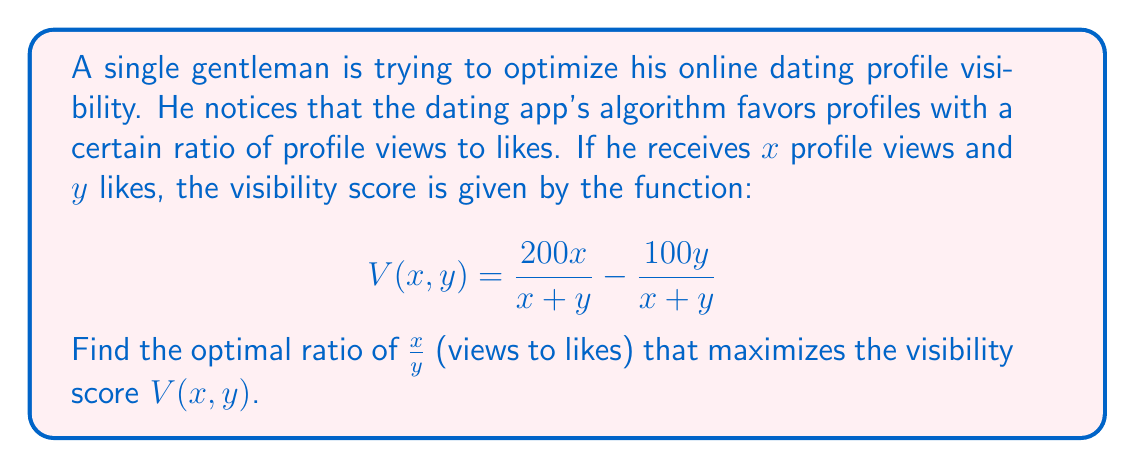Provide a solution to this math problem. To find the optimal ratio, we need to express the visibility score in terms of the ratio $r = \frac{x}{y}$ and then find the maximum value of this function.

1) Let $r = \frac{x}{y}$, so $x = ry$

2) Substitute this into the visibility score function:

   $$V(r) = \frac{200ry}{ry+y} - \frac{100y}{ry+y}$$

3) Simplify:

   $$V(r) = \frac{200r}{r+1} - \frac{100}{r+1}$$

4) To find the maximum, differentiate $V(r)$ with respect to $r$ and set it to zero:

   $$\frac{dV}{dr} = \frac{200(r+1) - 200r}{(r+1)^2} + \frac{100}{(r+1)^2} = \frac{200+100}{(r+1)^2} = \frac{300}{(r+1)^2}$$

5) Since $\frac{dV}{dr}$ is always positive (for positive $r$), the function $V(r)$ is always increasing. This means the optimal ratio is the largest possible value of $r$.

6) In practical terms, this means the gentleman should aim for the highest possible ratio of views to likes, ideally having many views and very few likes.

7) However, in reality, there would be an upper limit to this ratio. The app might have a maximum visibility score or other factors that come into play. Without more information, we can only conclude that the optimal strategy is to maximize views while minimizing likes.
Answer: The optimal ratio $\frac{x}{y}$ approaches infinity, meaning the visibility score is maximized when the number of views is much larger than the number of likes. 